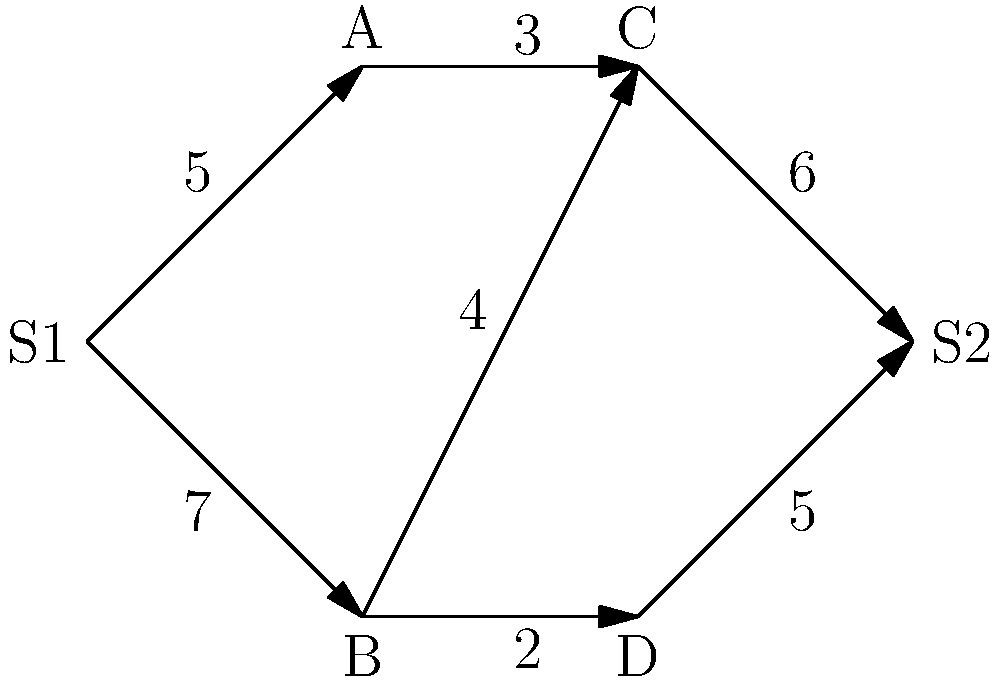In the network shown above, there are two sources (S1 and S2) and two sinks (A and D). The numbers on the edges represent their capacities. What is the maximum total flow that can be achieved from both sources to both sinks combined? To solve this problem, we need to follow these steps:

1) First, we need to transform this multiple-source, multiple-sink problem into a single-source, single-sink problem. We can do this by:
   a) Adding a super source S and connecting it to S1 and S2 with infinite capacity.
   b) Adding a super sink T and connecting A and D to it with infinite capacity.

2) Now we can apply the Ford-Fulkerson algorithm to find the maximum flow from S to T.

3) Let's find augmenting paths until no more exist:

   Path 1: S -> S1 -> B -> D -> T (flow: 2)
   Path 2: S -> S1 -> A -> C -> S2 -> T (flow: 3)
   Path 3: S -> S1 -> B -> C -> S2 -> T (flow: 2)
   Path 4: S -> S2 -> T (flow: 1)

4) The total maximum flow is the sum of these flows: 2 + 3 + 2 + 1 = 8

5) We can verify this by checking the flow across the cut (S1,S2) -> (A,B,C,D):
   S1 -> A: 3
   S1 -> B: 5
   S2 -> C: 0 (flow is in opposite direction)
   S2 -> D: 0
   Total: 3 + 5 = 8

Therefore, the maximum total flow that can be achieved from both sources to both sinks combined is 8.
Answer: 8 